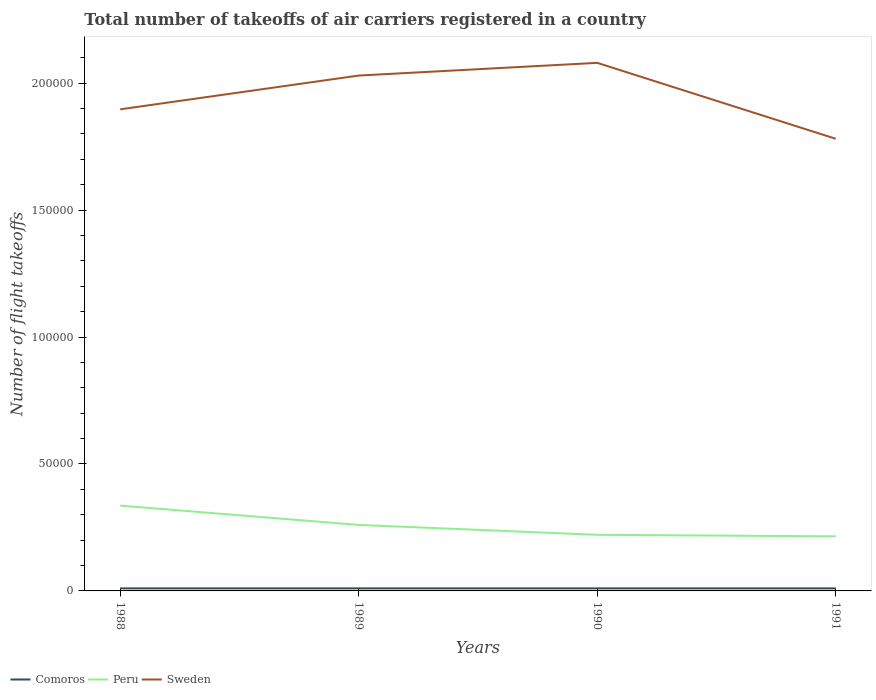Does the line corresponding to Peru intersect with the line corresponding to Sweden?
Ensure brevity in your answer.  No. Is the number of lines equal to the number of legend labels?
Provide a succinct answer. Yes. Across all years, what is the maximum total number of flight takeoffs in Peru?
Provide a succinct answer. 2.15e+04. In which year was the total number of flight takeoffs in Sweden maximum?
Provide a short and direct response. 1991. Is the total number of flight takeoffs in Comoros strictly greater than the total number of flight takeoffs in Sweden over the years?
Give a very brief answer. Yes. How many lines are there?
Offer a very short reply. 3. How many years are there in the graph?
Provide a succinct answer. 4. What is the difference between two consecutive major ticks on the Y-axis?
Make the answer very short. 5.00e+04. Are the values on the major ticks of Y-axis written in scientific E-notation?
Provide a short and direct response. No. Does the graph contain grids?
Ensure brevity in your answer.  No. Where does the legend appear in the graph?
Provide a short and direct response. Bottom left. What is the title of the graph?
Your answer should be compact. Total number of takeoffs of air carriers registered in a country. Does "Fiji" appear as one of the legend labels in the graph?
Provide a succinct answer. No. What is the label or title of the Y-axis?
Offer a terse response. Number of flight takeoffs. What is the Number of flight takeoffs of Comoros in 1988?
Keep it short and to the point. 1000. What is the Number of flight takeoffs of Peru in 1988?
Your answer should be very brief. 3.36e+04. What is the Number of flight takeoffs in Sweden in 1988?
Offer a terse response. 1.90e+05. What is the Number of flight takeoffs of Comoros in 1989?
Keep it short and to the point. 1000. What is the Number of flight takeoffs of Peru in 1989?
Ensure brevity in your answer.  2.60e+04. What is the Number of flight takeoffs in Sweden in 1989?
Ensure brevity in your answer.  2.03e+05. What is the Number of flight takeoffs in Peru in 1990?
Give a very brief answer. 2.21e+04. What is the Number of flight takeoffs of Sweden in 1990?
Offer a terse response. 2.08e+05. What is the Number of flight takeoffs of Peru in 1991?
Provide a succinct answer. 2.15e+04. What is the Number of flight takeoffs of Sweden in 1991?
Keep it short and to the point. 1.78e+05. Across all years, what is the maximum Number of flight takeoffs of Comoros?
Give a very brief answer. 1000. Across all years, what is the maximum Number of flight takeoffs in Peru?
Your answer should be very brief. 3.36e+04. Across all years, what is the maximum Number of flight takeoffs in Sweden?
Keep it short and to the point. 2.08e+05. Across all years, what is the minimum Number of flight takeoffs of Comoros?
Your answer should be very brief. 1000. Across all years, what is the minimum Number of flight takeoffs in Peru?
Ensure brevity in your answer.  2.15e+04. Across all years, what is the minimum Number of flight takeoffs in Sweden?
Your response must be concise. 1.78e+05. What is the total Number of flight takeoffs in Comoros in the graph?
Your answer should be compact. 4000. What is the total Number of flight takeoffs in Peru in the graph?
Provide a succinct answer. 1.03e+05. What is the total Number of flight takeoffs of Sweden in the graph?
Provide a succinct answer. 7.79e+05. What is the difference between the Number of flight takeoffs in Comoros in 1988 and that in 1989?
Provide a succinct answer. 0. What is the difference between the Number of flight takeoffs of Peru in 1988 and that in 1989?
Provide a short and direct response. 7600. What is the difference between the Number of flight takeoffs of Sweden in 1988 and that in 1989?
Offer a terse response. -1.33e+04. What is the difference between the Number of flight takeoffs of Peru in 1988 and that in 1990?
Provide a short and direct response. 1.15e+04. What is the difference between the Number of flight takeoffs in Sweden in 1988 and that in 1990?
Your answer should be very brief. -1.83e+04. What is the difference between the Number of flight takeoffs in Comoros in 1988 and that in 1991?
Your answer should be compact. 0. What is the difference between the Number of flight takeoffs in Peru in 1988 and that in 1991?
Make the answer very short. 1.21e+04. What is the difference between the Number of flight takeoffs in Sweden in 1988 and that in 1991?
Offer a very short reply. 1.16e+04. What is the difference between the Number of flight takeoffs of Comoros in 1989 and that in 1990?
Give a very brief answer. 0. What is the difference between the Number of flight takeoffs in Peru in 1989 and that in 1990?
Your response must be concise. 3900. What is the difference between the Number of flight takeoffs of Sweden in 1989 and that in 1990?
Keep it short and to the point. -5000. What is the difference between the Number of flight takeoffs of Peru in 1989 and that in 1991?
Keep it short and to the point. 4500. What is the difference between the Number of flight takeoffs in Sweden in 1989 and that in 1991?
Your response must be concise. 2.49e+04. What is the difference between the Number of flight takeoffs in Peru in 1990 and that in 1991?
Your answer should be very brief. 600. What is the difference between the Number of flight takeoffs of Sweden in 1990 and that in 1991?
Your response must be concise. 2.99e+04. What is the difference between the Number of flight takeoffs in Comoros in 1988 and the Number of flight takeoffs in Peru in 1989?
Offer a terse response. -2.50e+04. What is the difference between the Number of flight takeoffs in Comoros in 1988 and the Number of flight takeoffs in Sweden in 1989?
Provide a short and direct response. -2.02e+05. What is the difference between the Number of flight takeoffs in Peru in 1988 and the Number of flight takeoffs in Sweden in 1989?
Your answer should be very brief. -1.69e+05. What is the difference between the Number of flight takeoffs in Comoros in 1988 and the Number of flight takeoffs in Peru in 1990?
Offer a terse response. -2.11e+04. What is the difference between the Number of flight takeoffs of Comoros in 1988 and the Number of flight takeoffs of Sweden in 1990?
Offer a very short reply. -2.07e+05. What is the difference between the Number of flight takeoffs in Peru in 1988 and the Number of flight takeoffs in Sweden in 1990?
Ensure brevity in your answer.  -1.74e+05. What is the difference between the Number of flight takeoffs of Comoros in 1988 and the Number of flight takeoffs of Peru in 1991?
Provide a succinct answer. -2.05e+04. What is the difference between the Number of flight takeoffs in Comoros in 1988 and the Number of flight takeoffs in Sweden in 1991?
Keep it short and to the point. -1.77e+05. What is the difference between the Number of flight takeoffs in Peru in 1988 and the Number of flight takeoffs in Sweden in 1991?
Provide a short and direct response. -1.44e+05. What is the difference between the Number of flight takeoffs in Comoros in 1989 and the Number of flight takeoffs in Peru in 1990?
Keep it short and to the point. -2.11e+04. What is the difference between the Number of flight takeoffs of Comoros in 1989 and the Number of flight takeoffs of Sweden in 1990?
Give a very brief answer. -2.07e+05. What is the difference between the Number of flight takeoffs in Peru in 1989 and the Number of flight takeoffs in Sweden in 1990?
Offer a very short reply. -1.82e+05. What is the difference between the Number of flight takeoffs in Comoros in 1989 and the Number of flight takeoffs in Peru in 1991?
Your answer should be compact. -2.05e+04. What is the difference between the Number of flight takeoffs of Comoros in 1989 and the Number of flight takeoffs of Sweden in 1991?
Your answer should be very brief. -1.77e+05. What is the difference between the Number of flight takeoffs in Peru in 1989 and the Number of flight takeoffs in Sweden in 1991?
Give a very brief answer. -1.52e+05. What is the difference between the Number of flight takeoffs of Comoros in 1990 and the Number of flight takeoffs of Peru in 1991?
Your response must be concise. -2.05e+04. What is the difference between the Number of flight takeoffs in Comoros in 1990 and the Number of flight takeoffs in Sweden in 1991?
Give a very brief answer. -1.77e+05. What is the difference between the Number of flight takeoffs of Peru in 1990 and the Number of flight takeoffs of Sweden in 1991?
Keep it short and to the point. -1.56e+05. What is the average Number of flight takeoffs of Peru per year?
Offer a terse response. 2.58e+04. What is the average Number of flight takeoffs of Sweden per year?
Provide a succinct answer. 1.95e+05. In the year 1988, what is the difference between the Number of flight takeoffs of Comoros and Number of flight takeoffs of Peru?
Your answer should be very brief. -3.26e+04. In the year 1988, what is the difference between the Number of flight takeoffs in Comoros and Number of flight takeoffs in Sweden?
Keep it short and to the point. -1.89e+05. In the year 1988, what is the difference between the Number of flight takeoffs of Peru and Number of flight takeoffs of Sweden?
Provide a succinct answer. -1.56e+05. In the year 1989, what is the difference between the Number of flight takeoffs of Comoros and Number of flight takeoffs of Peru?
Your response must be concise. -2.50e+04. In the year 1989, what is the difference between the Number of flight takeoffs in Comoros and Number of flight takeoffs in Sweden?
Your answer should be compact. -2.02e+05. In the year 1989, what is the difference between the Number of flight takeoffs of Peru and Number of flight takeoffs of Sweden?
Offer a very short reply. -1.77e+05. In the year 1990, what is the difference between the Number of flight takeoffs of Comoros and Number of flight takeoffs of Peru?
Offer a terse response. -2.11e+04. In the year 1990, what is the difference between the Number of flight takeoffs in Comoros and Number of flight takeoffs in Sweden?
Offer a very short reply. -2.07e+05. In the year 1990, what is the difference between the Number of flight takeoffs of Peru and Number of flight takeoffs of Sweden?
Your answer should be compact. -1.86e+05. In the year 1991, what is the difference between the Number of flight takeoffs in Comoros and Number of flight takeoffs in Peru?
Give a very brief answer. -2.05e+04. In the year 1991, what is the difference between the Number of flight takeoffs in Comoros and Number of flight takeoffs in Sweden?
Provide a succinct answer. -1.77e+05. In the year 1991, what is the difference between the Number of flight takeoffs in Peru and Number of flight takeoffs in Sweden?
Provide a succinct answer. -1.57e+05. What is the ratio of the Number of flight takeoffs in Comoros in 1988 to that in 1989?
Ensure brevity in your answer.  1. What is the ratio of the Number of flight takeoffs in Peru in 1988 to that in 1989?
Ensure brevity in your answer.  1.29. What is the ratio of the Number of flight takeoffs in Sweden in 1988 to that in 1989?
Make the answer very short. 0.93. What is the ratio of the Number of flight takeoffs in Comoros in 1988 to that in 1990?
Provide a succinct answer. 1. What is the ratio of the Number of flight takeoffs in Peru in 1988 to that in 1990?
Provide a short and direct response. 1.52. What is the ratio of the Number of flight takeoffs of Sweden in 1988 to that in 1990?
Offer a terse response. 0.91. What is the ratio of the Number of flight takeoffs of Peru in 1988 to that in 1991?
Provide a short and direct response. 1.56. What is the ratio of the Number of flight takeoffs of Sweden in 1988 to that in 1991?
Your answer should be very brief. 1.07. What is the ratio of the Number of flight takeoffs in Peru in 1989 to that in 1990?
Keep it short and to the point. 1.18. What is the ratio of the Number of flight takeoffs in Peru in 1989 to that in 1991?
Your answer should be compact. 1.21. What is the ratio of the Number of flight takeoffs in Sweden in 1989 to that in 1991?
Give a very brief answer. 1.14. What is the ratio of the Number of flight takeoffs of Comoros in 1990 to that in 1991?
Provide a short and direct response. 1. What is the ratio of the Number of flight takeoffs in Peru in 1990 to that in 1991?
Offer a terse response. 1.03. What is the ratio of the Number of flight takeoffs of Sweden in 1990 to that in 1991?
Ensure brevity in your answer.  1.17. What is the difference between the highest and the second highest Number of flight takeoffs of Peru?
Offer a terse response. 7600. What is the difference between the highest and the second highest Number of flight takeoffs in Sweden?
Your answer should be compact. 5000. What is the difference between the highest and the lowest Number of flight takeoffs of Peru?
Offer a terse response. 1.21e+04. What is the difference between the highest and the lowest Number of flight takeoffs of Sweden?
Your answer should be compact. 2.99e+04. 